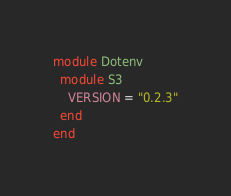<code> <loc_0><loc_0><loc_500><loc_500><_Ruby_>module Dotenv
  module S3
    VERSION = "0.2.3"
  end
end
</code> 